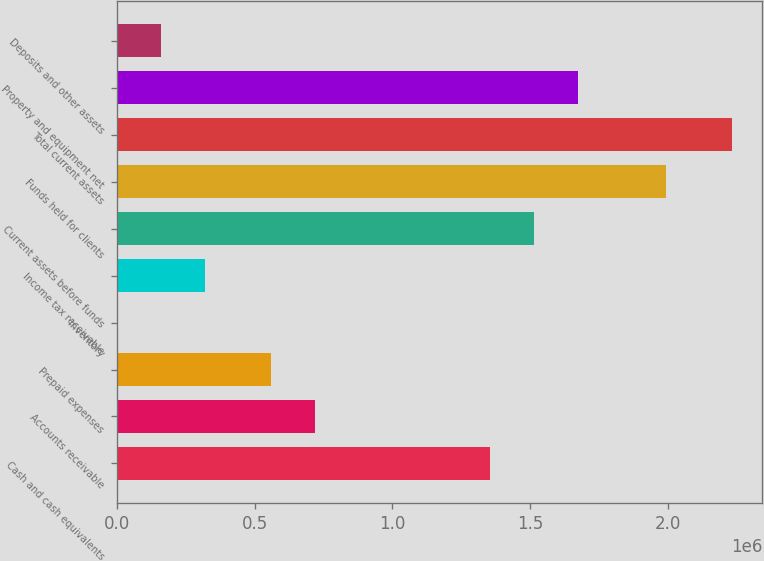<chart> <loc_0><loc_0><loc_500><loc_500><bar_chart><fcel>Cash and cash equivalents<fcel>Accounts receivable<fcel>Prepaid expenses<fcel>Inventory<fcel>Income tax receivable<fcel>Current assets before funds<fcel>Funds held for clients<fcel>Total current assets<fcel>Property and equipment net<fcel>Deposits and other assets<nl><fcel>1.35561e+06<fcel>717767<fcel>558306<fcel>195<fcel>319116<fcel>1.51507e+06<fcel>1.99345e+06<fcel>2.23264e+06<fcel>1.67453e+06<fcel>159655<nl></chart> 